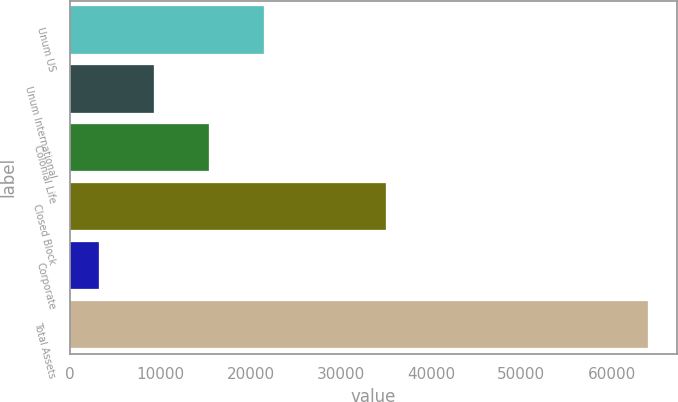Convert chart to OTSL. <chart><loc_0><loc_0><loc_500><loc_500><bar_chart><fcel>Unum US<fcel>Unum International<fcel>Colonial Life<fcel>Closed Block<fcel>Corporate<fcel>Total Assets<nl><fcel>21472.3<fcel>9317.85<fcel>15395.1<fcel>35051.2<fcel>3240.6<fcel>64013.1<nl></chart> 